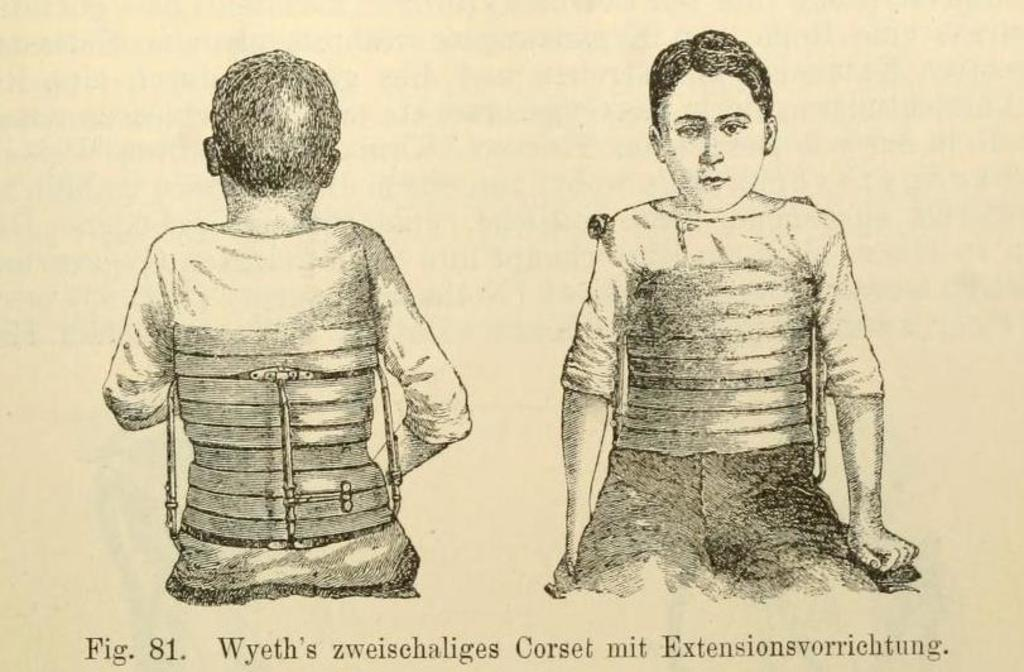What is the main subject of the picture? The main subject of the picture is a printed image of a boy. Is the image of the boy visible on both sides of the picture? Yes, the image of the boy is printed on both the front and back sides. What else can be seen at the bottom of the picture? There is text at the bottom of the picture. How many deer are present in the picture? There are no deer visible in the picture; it features a printed image of a boy. What type of quilt is used to cover the boy in the picture? There is no quilt present in the picture; it is a printed image of a boy with text at the bottom. 